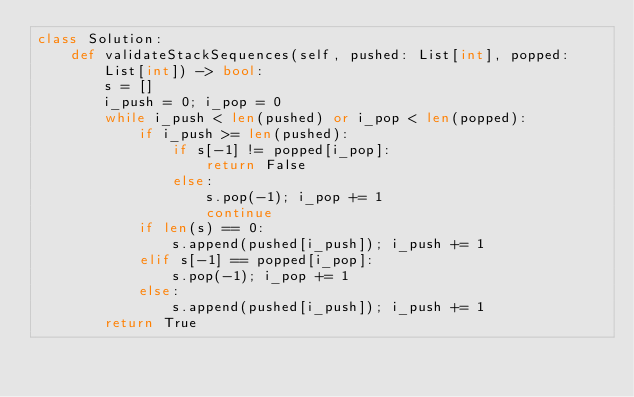Convert code to text. <code><loc_0><loc_0><loc_500><loc_500><_Python_>class Solution:
    def validateStackSequences(self, pushed: List[int], popped: List[int]) -> bool:
        s = []
        i_push = 0; i_pop = 0
        while i_push < len(pushed) or i_pop < len(popped):
            if i_push >= len(pushed):
                if s[-1] != popped[i_pop]:
                    return False
                else:
                    s.pop(-1); i_pop += 1
                    continue
            if len(s) == 0:
                s.append(pushed[i_push]); i_push += 1
            elif s[-1] == popped[i_pop]:
                s.pop(-1); i_pop += 1
            else:
                s.append(pushed[i_push]); i_push += 1
        return True
</code> 